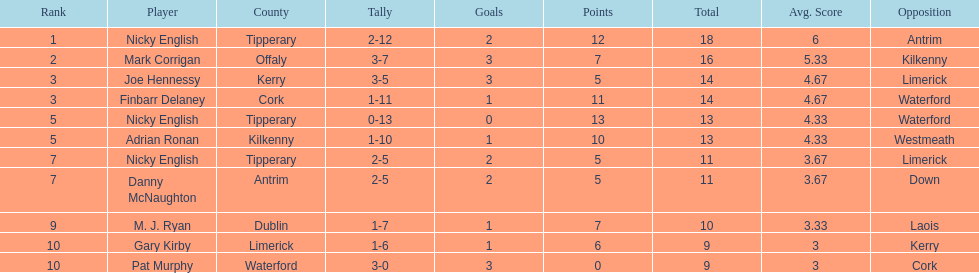How many times was waterford the opposition? 2. Could you help me parse every detail presented in this table? {'header': ['Rank', 'Player', 'County', 'Tally', 'Goals', 'Points', 'Total', 'Avg. Score', 'Opposition'], 'rows': [['1', 'Nicky English', 'Tipperary', '2-12', '2', '12', '18', '6', 'Antrim'], ['2', 'Mark Corrigan', 'Offaly', '3-7', '3', '7', '16', '5.33', 'Kilkenny'], ['3', 'Joe Hennessy', 'Kerry', '3-5', '3', '5', '14', '4.67', 'Limerick'], ['3', 'Finbarr Delaney', 'Cork', '1-11', '1', '11', '14', '4.67', 'Waterford'], ['5', 'Nicky English', 'Tipperary', '0-13', '0', '13', '13', '4.33', 'Waterford'], ['5', 'Adrian Ronan', 'Kilkenny', '1-10', '1', '10', '13', '4.33', 'Westmeath'], ['7', 'Nicky English', 'Tipperary', '2-5', '2', '5', '11', '3.67', 'Limerick'], ['7', 'Danny McNaughton', 'Antrim', '2-5', '2', '5', '11', '3.67', 'Down'], ['9', 'M. J. Ryan', 'Dublin', '1-7', '1', '7', '10', '3.33', 'Laois'], ['10', 'Gary Kirby', 'Limerick', '1-6', '1', '6', '9', '3', 'Kerry'], ['10', 'Pat Murphy', 'Waterford', '3-0', '3', '0', '9', '3', 'Cork']]} 